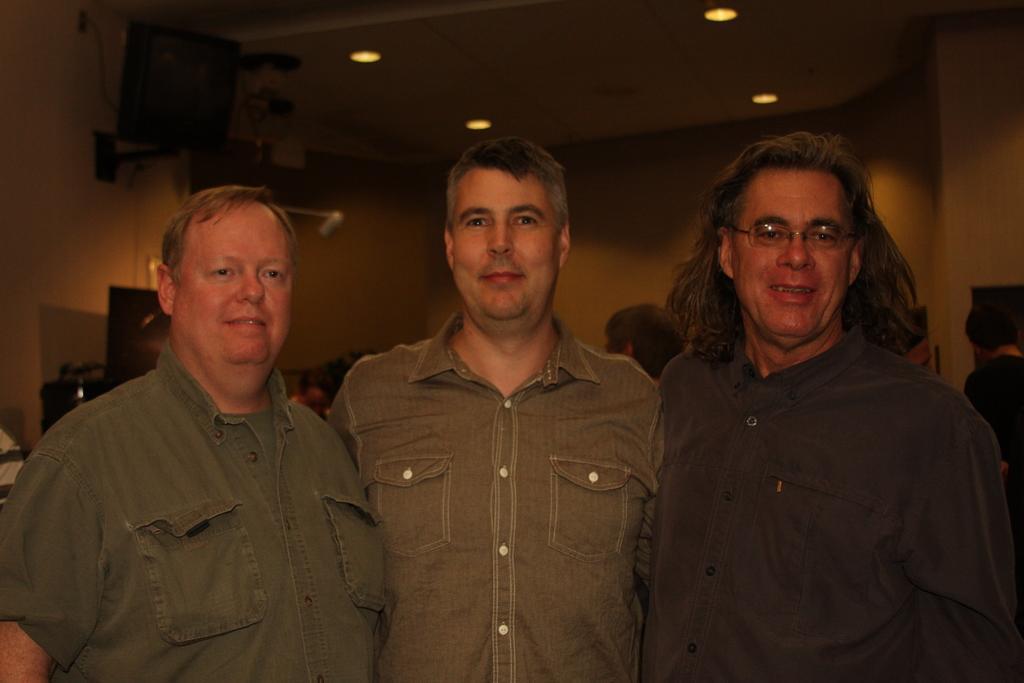Can you describe this image briefly? In this image there are three persons standing and smiling, and in the background there are group of people, lights, wall. 